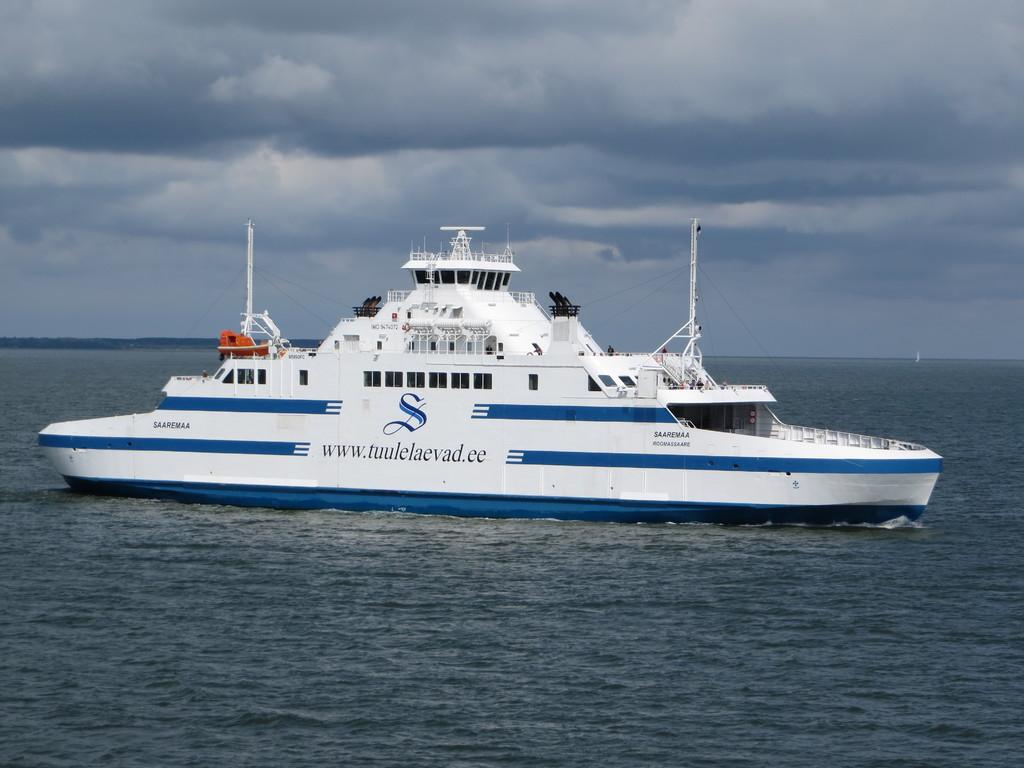What type of vehicle is in the image? There is a blue and white color ship in the image. What is the ship situated on or in? There is water visible in the image. What is the color of the sky in the image? The sky is blue and white in color. What type of hair can be seen on the cast in the image? There is no cast or hair present in the image; it features a blue and white color ship on water with a blue and white sky. 